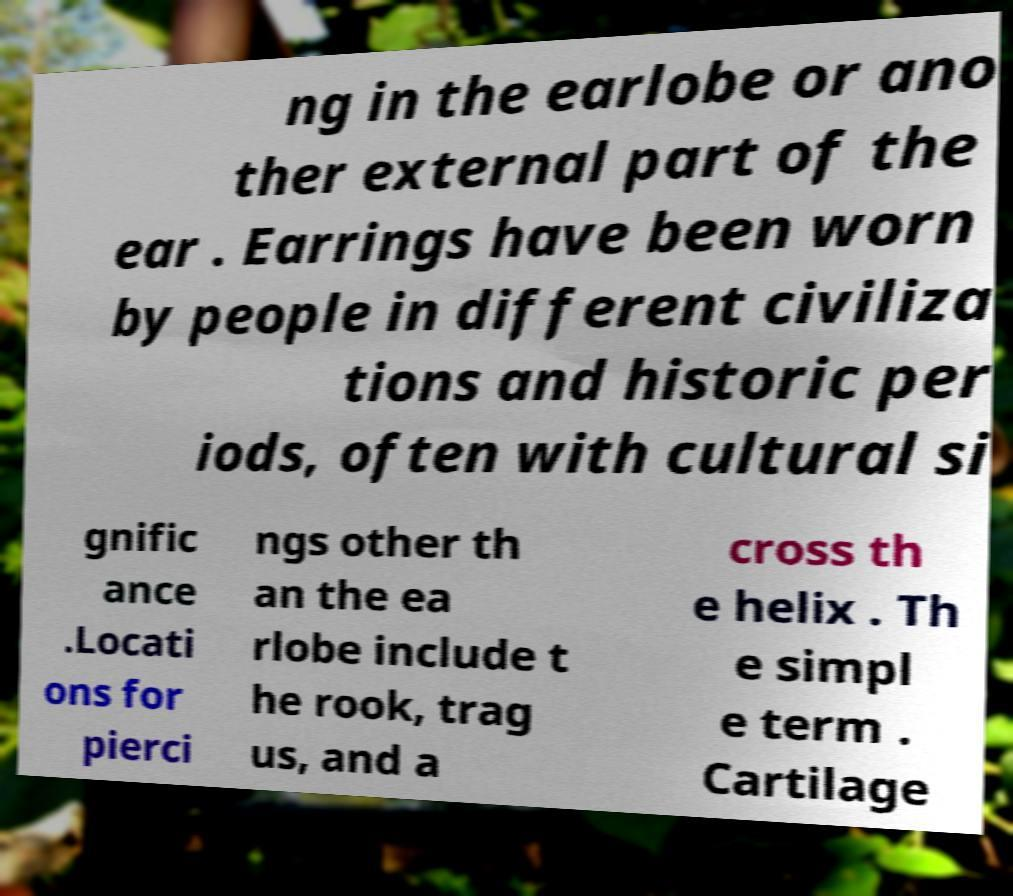Can you accurately transcribe the text from the provided image for me? ng in the earlobe or ano ther external part of the ear . Earrings have been worn by people in different civiliza tions and historic per iods, often with cultural si gnific ance .Locati ons for pierci ngs other th an the ea rlobe include t he rook, trag us, and a cross th e helix . Th e simpl e term . Cartilage 